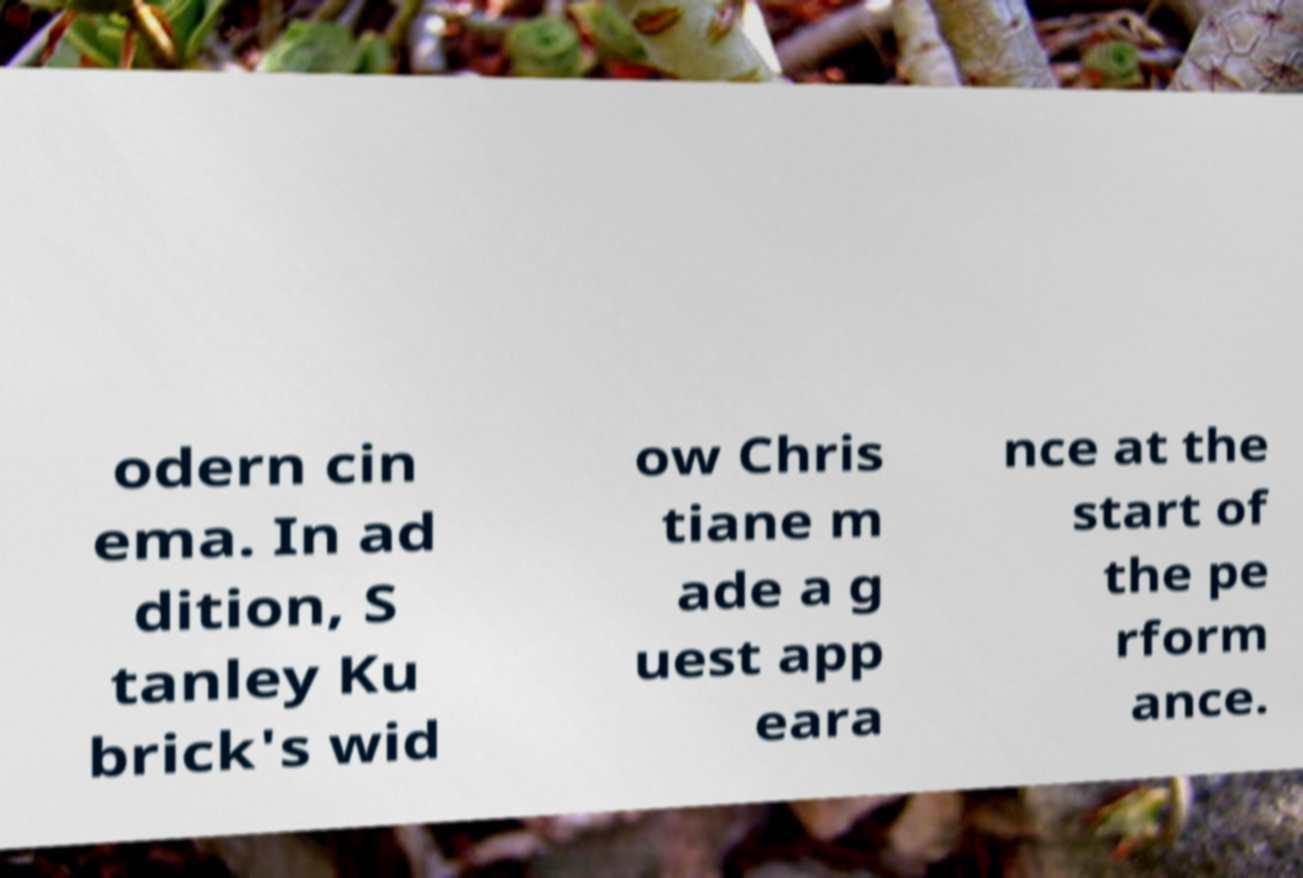For documentation purposes, I need the text within this image transcribed. Could you provide that? odern cin ema. In ad dition, S tanley Ku brick's wid ow Chris tiane m ade a g uest app eara nce at the start of the pe rform ance. 